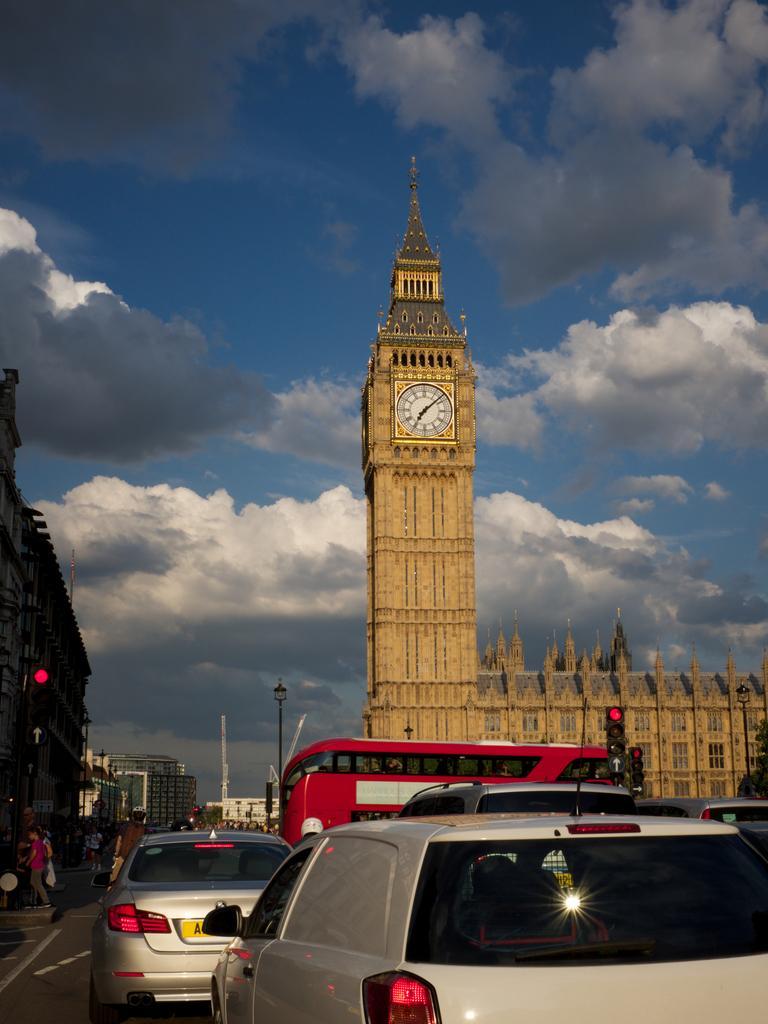Could you give a brief overview of what you see in this image? In this picture we can see some vehicles on the road, in the background there are some buildings, we can see some people, poles and traffic lights in the middle, on the right side there is a clock tower, we can see the sky and clouds at the top of the picture. 